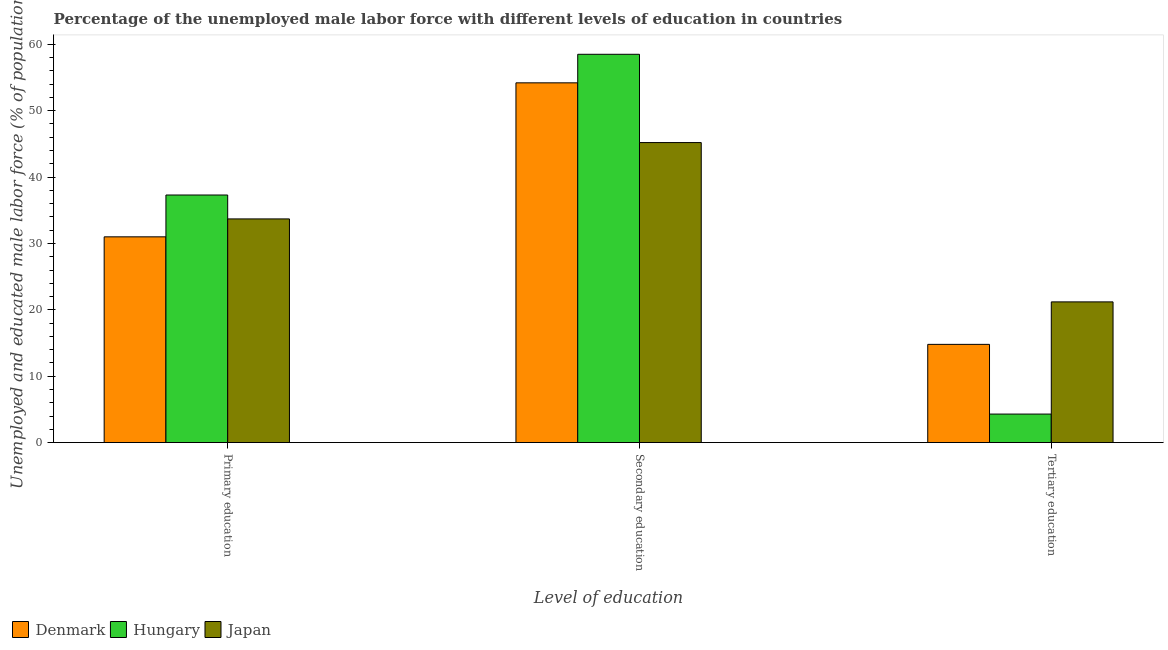How many groups of bars are there?
Offer a very short reply. 3. Are the number of bars per tick equal to the number of legend labels?
Give a very brief answer. Yes. What is the label of the 1st group of bars from the left?
Ensure brevity in your answer.  Primary education. What is the percentage of male labor force who received secondary education in Japan?
Make the answer very short. 45.2. Across all countries, what is the maximum percentage of male labor force who received tertiary education?
Your response must be concise. 21.2. In which country was the percentage of male labor force who received secondary education maximum?
Offer a very short reply. Hungary. What is the total percentage of male labor force who received tertiary education in the graph?
Your answer should be compact. 40.3. What is the difference between the percentage of male labor force who received tertiary education in Hungary and that in Japan?
Offer a very short reply. -16.9. What is the difference between the percentage of male labor force who received tertiary education in Denmark and the percentage of male labor force who received primary education in Hungary?
Your answer should be compact. -22.5. What is the difference between the percentage of male labor force who received tertiary education and percentage of male labor force who received primary education in Hungary?
Give a very brief answer. -33. In how many countries, is the percentage of male labor force who received tertiary education greater than 44 %?
Your response must be concise. 0. What is the ratio of the percentage of male labor force who received secondary education in Denmark to that in Japan?
Provide a succinct answer. 1.2. Is the percentage of male labor force who received tertiary education in Denmark less than that in Japan?
Provide a short and direct response. Yes. Is the difference between the percentage of male labor force who received secondary education in Japan and Denmark greater than the difference between the percentage of male labor force who received primary education in Japan and Denmark?
Your answer should be compact. No. What is the difference between the highest and the second highest percentage of male labor force who received tertiary education?
Offer a terse response. 6.4. What is the difference between the highest and the lowest percentage of male labor force who received tertiary education?
Give a very brief answer. 16.9. What does the 2nd bar from the left in Primary education represents?
Offer a terse response. Hungary. What does the 2nd bar from the right in Primary education represents?
Ensure brevity in your answer.  Hungary. Is it the case that in every country, the sum of the percentage of male labor force who received primary education and percentage of male labor force who received secondary education is greater than the percentage of male labor force who received tertiary education?
Your response must be concise. Yes. How many bars are there?
Give a very brief answer. 9. How many countries are there in the graph?
Provide a short and direct response. 3. What is the difference between two consecutive major ticks on the Y-axis?
Ensure brevity in your answer.  10. Does the graph contain grids?
Provide a short and direct response. No. Where does the legend appear in the graph?
Give a very brief answer. Bottom left. How are the legend labels stacked?
Ensure brevity in your answer.  Horizontal. What is the title of the graph?
Offer a very short reply. Percentage of the unemployed male labor force with different levels of education in countries. Does "Honduras" appear as one of the legend labels in the graph?
Offer a very short reply. No. What is the label or title of the X-axis?
Your response must be concise. Level of education. What is the label or title of the Y-axis?
Provide a short and direct response. Unemployed and educated male labor force (% of population). What is the Unemployed and educated male labor force (% of population) of Hungary in Primary education?
Your answer should be compact. 37.3. What is the Unemployed and educated male labor force (% of population) of Japan in Primary education?
Keep it short and to the point. 33.7. What is the Unemployed and educated male labor force (% of population) of Denmark in Secondary education?
Give a very brief answer. 54.2. What is the Unemployed and educated male labor force (% of population) in Hungary in Secondary education?
Keep it short and to the point. 58.5. What is the Unemployed and educated male labor force (% of population) in Japan in Secondary education?
Your answer should be compact. 45.2. What is the Unemployed and educated male labor force (% of population) of Denmark in Tertiary education?
Provide a short and direct response. 14.8. What is the Unemployed and educated male labor force (% of population) of Hungary in Tertiary education?
Make the answer very short. 4.3. What is the Unemployed and educated male labor force (% of population) in Japan in Tertiary education?
Provide a short and direct response. 21.2. Across all Level of education, what is the maximum Unemployed and educated male labor force (% of population) in Denmark?
Provide a short and direct response. 54.2. Across all Level of education, what is the maximum Unemployed and educated male labor force (% of population) of Hungary?
Provide a succinct answer. 58.5. Across all Level of education, what is the maximum Unemployed and educated male labor force (% of population) in Japan?
Your answer should be very brief. 45.2. Across all Level of education, what is the minimum Unemployed and educated male labor force (% of population) of Denmark?
Offer a terse response. 14.8. Across all Level of education, what is the minimum Unemployed and educated male labor force (% of population) in Hungary?
Offer a very short reply. 4.3. Across all Level of education, what is the minimum Unemployed and educated male labor force (% of population) of Japan?
Keep it short and to the point. 21.2. What is the total Unemployed and educated male labor force (% of population) of Denmark in the graph?
Ensure brevity in your answer.  100. What is the total Unemployed and educated male labor force (% of population) in Hungary in the graph?
Your answer should be very brief. 100.1. What is the total Unemployed and educated male labor force (% of population) in Japan in the graph?
Give a very brief answer. 100.1. What is the difference between the Unemployed and educated male labor force (% of population) of Denmark in Primary education and that in Secondary education?
Your answer should be very brief. -23.2. What is the difference between the Unemployed and educated male labor force (% of population) of Hungary in Primary education and that in Secondary education?
Your answer should be very brief. -21.2. What is the difference between the Unemployed and educated male labor force (% of population) in Denmark in Primary education and that in Tertiary education?
Offer a terse response. 16.2. What is the difference between the Unemployed and educated male labor force (% of population) in Japan in Primary education and that in Tertiary education?
Give a very brief answer. 12.5. What is the difference between the Unemployed and educated male labor force (% of population) in Denmark in Secondary education and that in Tertiary education?
Give a very brief answer. 39.4. What is the difference between the Unemployed and educated male labor force (% of population) of Hungary in Secondary education and that in Tertiary education?
Make the answer very short. 54.2. What is the difference between the Unemployed and educated male labor force (% of population) of Japan in Secondary education and that in Tertiary education?
Give a very brief answer. 24. What is the difference between the Unemployed and educated male labor force (% of population) of Denmark in Primary education and the Unemployed and educated male labor force (% of population) of Hungary in Secondary education?
Ensure brevity in your answer.  -27.5. What is the difference between the Unemployed and educated male labor force (% of population) in Denmark in Primary education and the Unemployed and educated male labor force (% of population) in Japan in Secondary education?
Give a very brief answer. -14.2. What is the difference between the Unemployed and educated male labor force (% of population) in Denmark in Primary education and the Unemployed and educated male labor force (% of population) in Hungary in Tertiary education?
Give a very brief answer. 26.7. What is the difference between the Unemployed and educated male labor force (% of population) of Denmark in Secondary education and the Unemployed and educated male labor force (% of population) of Hungary in Tertiary education?
Offer a very short reply. 49.9. What is the difference between the Unemployed and educated male labor force (% of population) in Denmark in Secondary education and the Unemployed and educated male labor force (% of population) in Japan in Tertiary education?
Offer a terse response. 33. What is the difference between the Unemployed and educated male labor force (% of population) of Hungary in Secondary education and the Unemployed and educated male labor force (% of population) of Japan in Tertiary education?
Give a very brief answer. 37.3. What is the average Unemployed and educated male labor force (% of population) in Denmark per Level of education?
Provide a succinct answer. 33.33. What is the average Unemployed and educated male labor force (% of population) of Hungary per Level of education?
Ensure brevity in your answer.  33.37. What is the average Unemployed and educated male labor force (% of population) in Japan per Level of education?
Your answer should be very brief. 33.37. What is the difference between the Unemployed and educated male labor force (% of population) in Denmark and Unemployed and educated male labor force (% of population) in Hungary in Secondary education?
Provide a short and direct response. -4.3. What is the difference between the Unemployed and educated male labor force (% of population) in Hungary and Unemployed and educated male labor force (% of population) in Japan in Secondary education?
Give a very brief answer. 13.3. What is the difference between the Unemployed and educated male labor force (% of population) in Hungary and Unemployed and educated male labor force (% of population) in Japan in Tertiary education?
Your response must be concise. -16.9. What is the ratio of the Unemployed and educated male labor force (% of population) of Denmark in Primary education to that in Secondary education?
Your response must be concise. 0.57. What is the ratio of the Unemployed and educated male labor force (% of population) of Hungary in Primary education to that in Secondary education?
Offer a terse response. 0.64. What is the ratio of the Unemployed and educated male labor force (% of population) in Japan in Primary education to that in Secondary education?
Make the answer very short. 0.75. What is the ratio of the Unemployed and educated male labor force (% of population) of Denmark in Primary education to that in Tertiary education?
Provide a short and direct response. 2.09. What is the ratio of the Unemployed and educated male labor force (% of population) of Hungary in Primary education to that in Tertiary education?
Provide a succinct answer. 8.67. What is the ratio of the Unemployed and educated male labor force (% of population) in Japan in Primary education to that in Tertiary education?
Offer a terse response. 1.59. What is the ratio of the Unemployed and educated male labor force (% of population) in Denmark in Secondary education to that in Tertiary education?
Keep it short and to the point. 3.66. What is the ratio of the Unemployed and educated male labor force (% of population) in Hungary in Secondary education to that in Tertiary education?
Provide a short and direct response. 13.6. What is the ratio of the Unemployed and educated male labor force (% of population) of Japan in Secondary education to that in Tertiary education?
Keep it short and to the point. 2.13. What is the difference between the highest and the second highest Unemployed and educated male labor force (% of population) in Denmark?
Your response must be concise. 23.2. What is the difference between the highest and the second highest Unemployed and educated male labor force (% of population) in Hungary?
Give a very brief answer. 21.2. What is the difference between the highest and the second highest Unemployed and educated male labor force (% of population) in Japan?
Keep it short and to the point. 11.5. What is the difference between the highest and the lowest Unemployed and educated male labor force (% of population) of Denmark?
Give a very brief answer. 39.4. What is the difference between the highest and the lowest Unemployed and educated male labor force (% of population) in Hungary?
Your answer should be very brief. 54.2. 